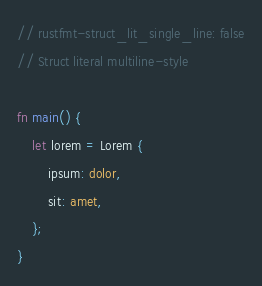<code> <loc_0><loc_0><loc_500><loc_500><_Rust_>// rustfmt-struct_lit_single_line: false
// Struct literal multiline-style

fn main() {
    let lorem = Lorem {
        ipsum: dolor,
        sit: amet,
    };
}
</code> 